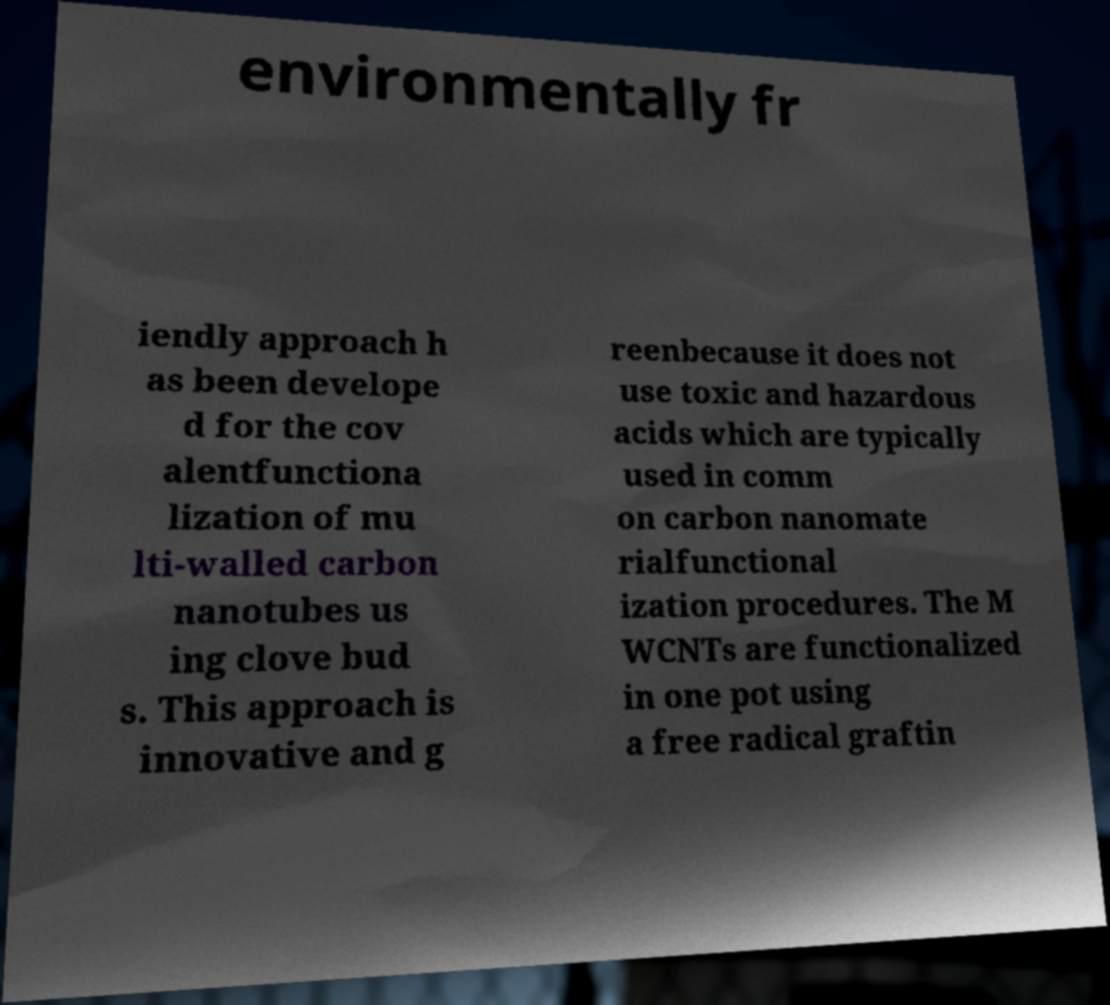Could you assist in decoding the text presented in this image and type it out clearly? environmentally fr iendly approach h as been develope d for the cov alentfunctiona lization of mu lti-walled carbon nanotubes us ing clove bud s. This approach is innovative and g reenbecause it does not use toxic and hazardous acids which are typically used in comm on carbon nanomate rialfunctional ization procedures. The M WCNTs are functionalized in one pot using a free radical graftin 